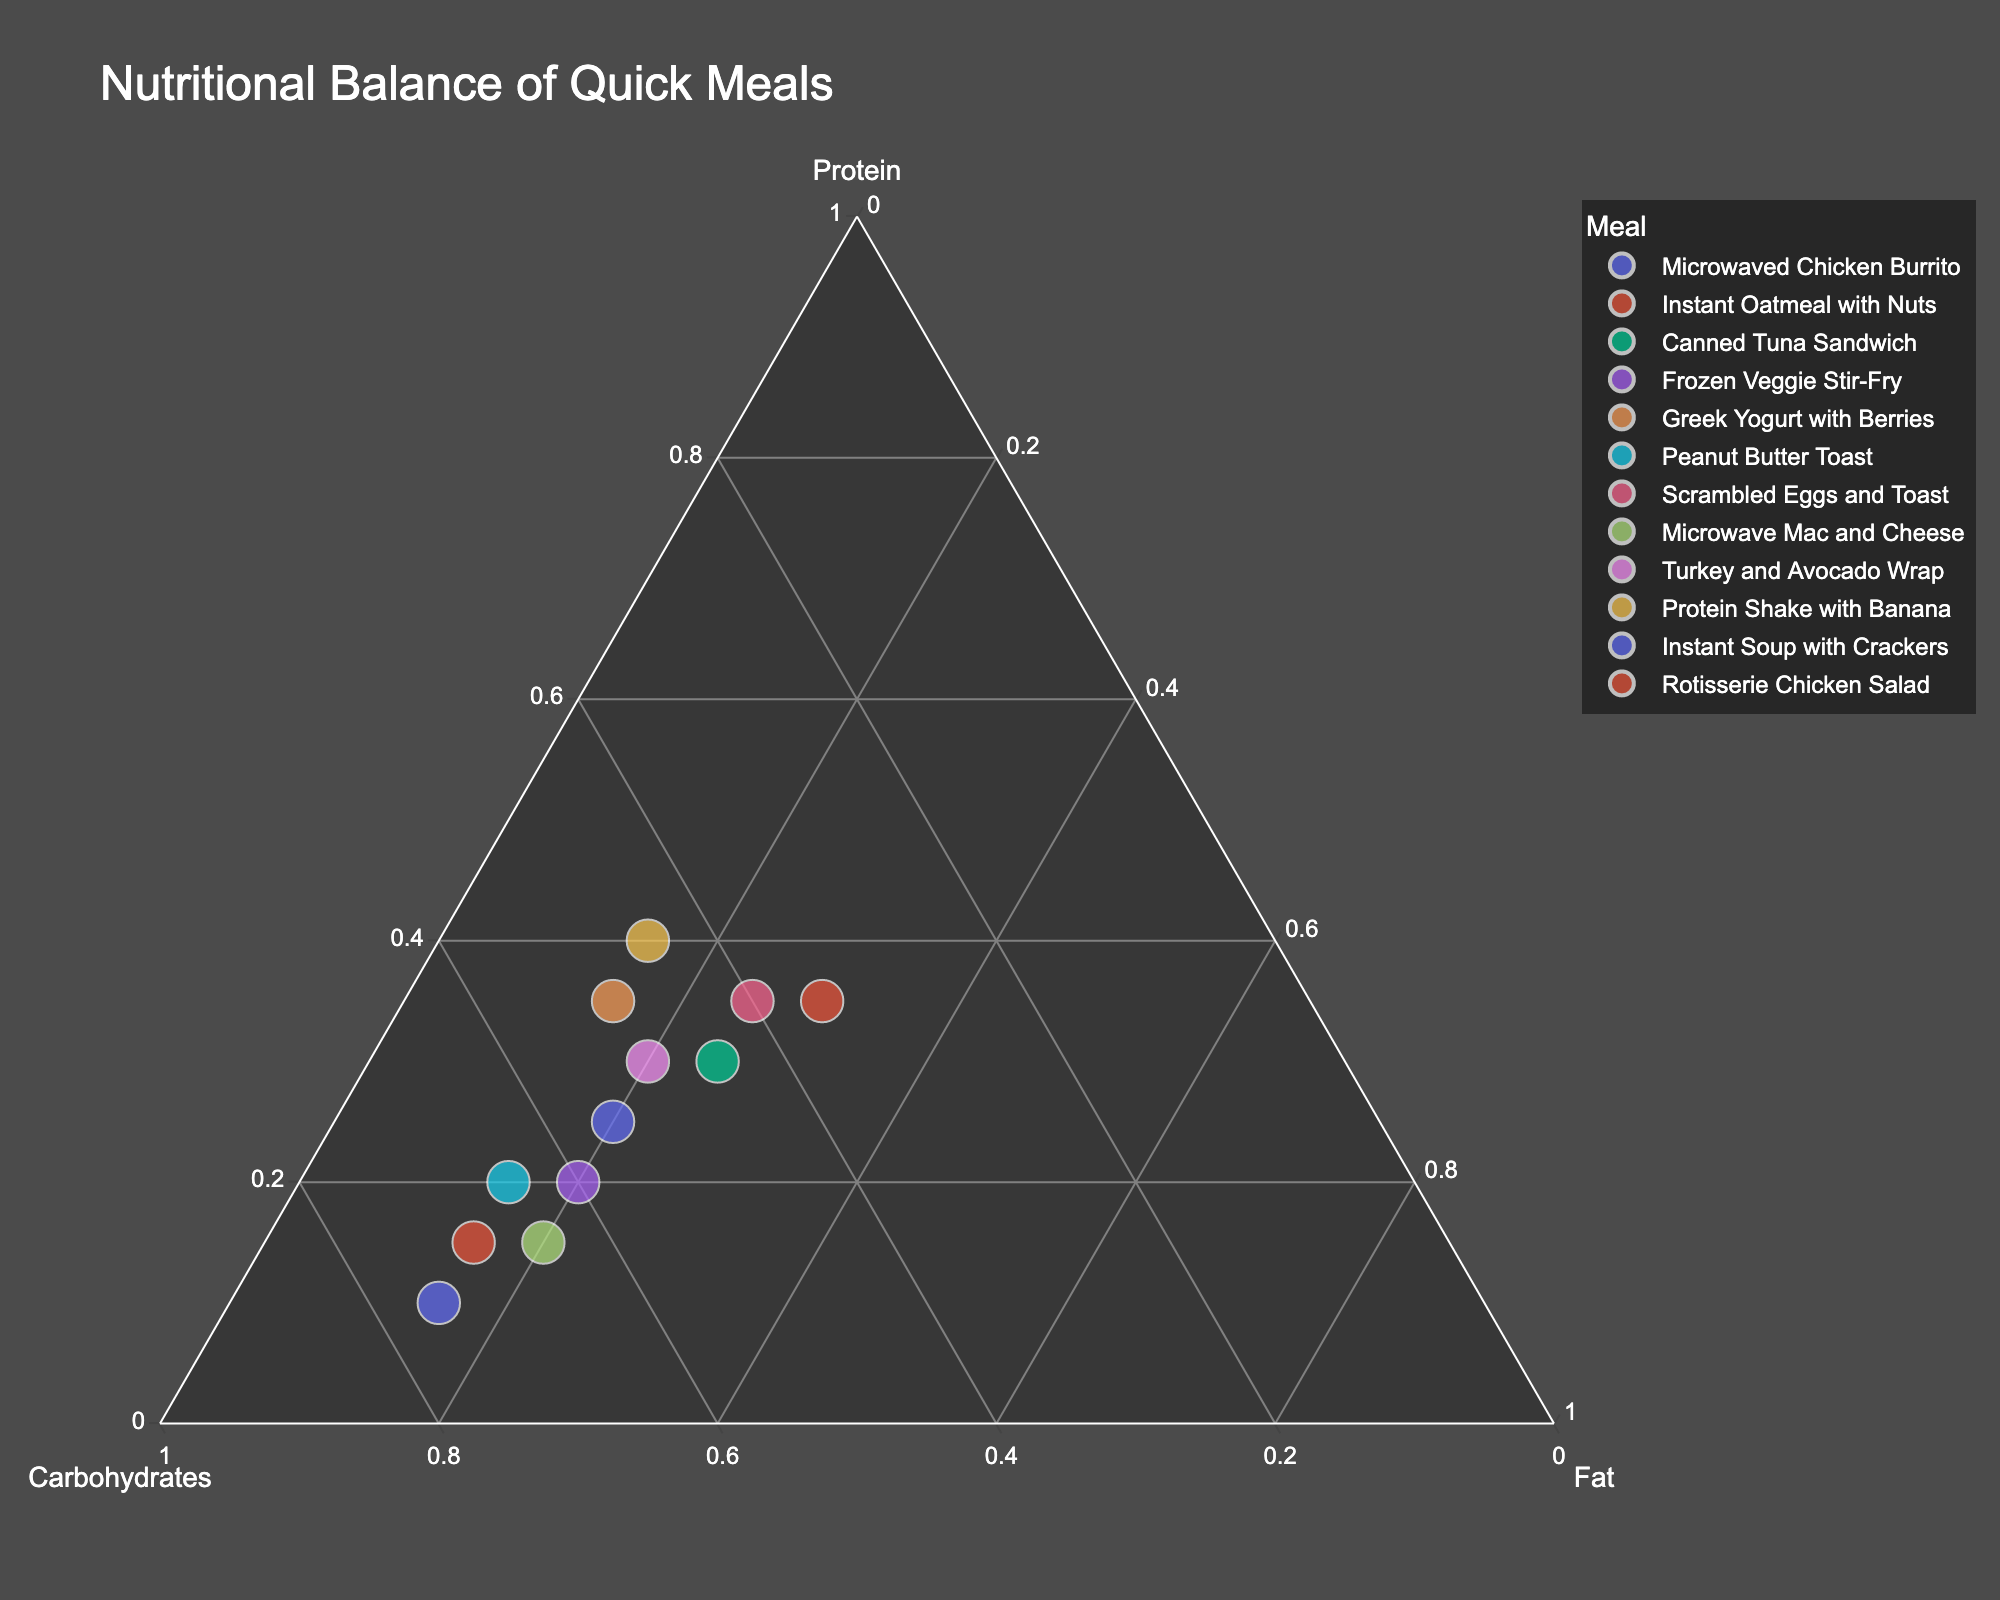What's the title of the plot? The title is clearly displayed at the top of the plot. By reading it, we can understand the focus of the plot.
Answer: Nutritional Balance of Quick Meals How many meals are represented in the plot? To find the number of meals, count the distinct data points in the plot. There are as many data points as there are entries in the dataset.
Answer: 12 Which meal has the highest proportion of protein? Identify the meal whose data point is closest to the protein vertex of the ternary plot. This corresponds to the meal with the highest value on the protein axis.
Answer: Protein Shake with Banana Which meal has the highest proportion of carbohydrates? Find the meal located nearest to the carbohydrates vertex, where the carbohydrate proportion is highest.
Answer: Instant Soup with Crackers Which meal has an equal proportion of protein and carbohydrates? Look for the data point that is equidistant from the protein and carbohydrates vertices, indicating equal proportions.
Answer: Rotisserie Chicken Salad What is the range of fat content across all meals? Identify the meal with the highest and lowest fat content by observing positions relative to the fat axis, then calculate the difference between these values.
Answer: 15% to 30% How does the protein content in the Microwaved Chicken Burrito compare to the Greek Yogurt with Berries? Compare the proximity of both meals’ data points to the protein axis, identifying which one is closer, indicating higher protein content.
Answer: Greek Yogurt with Berries has more protein Which meal is closest to having a balanced nutritional profile (equal parts protein, carbohydrates, and fats)? Locate the data point closest to the center of the plot, indicating near-equal proportions of all three nutrients.
Answer: Instant Oatmeal with Nuts Which meals have the same proportion of fat content? Identify data points that align horizontally with the same value on the fat axis.
Answer: Microwaved Chicken Burrito, Instant Oatmeal with Nuts, Frozen Veggie Stir-Fry, Peanut Butter Toast, Microwave Mac and Cheese, Instant Soup with Crackers, and Protein Shake with Banana What is the nutritional profile for the Canned Tuna Sandwich? Hover over the data point representing the Canned Tuna Sandwich to display its proportions of protein, carbohydrates, and fats.
Answer: Protein: 30%, Carbohydrates: 45%, Fat: 25% 